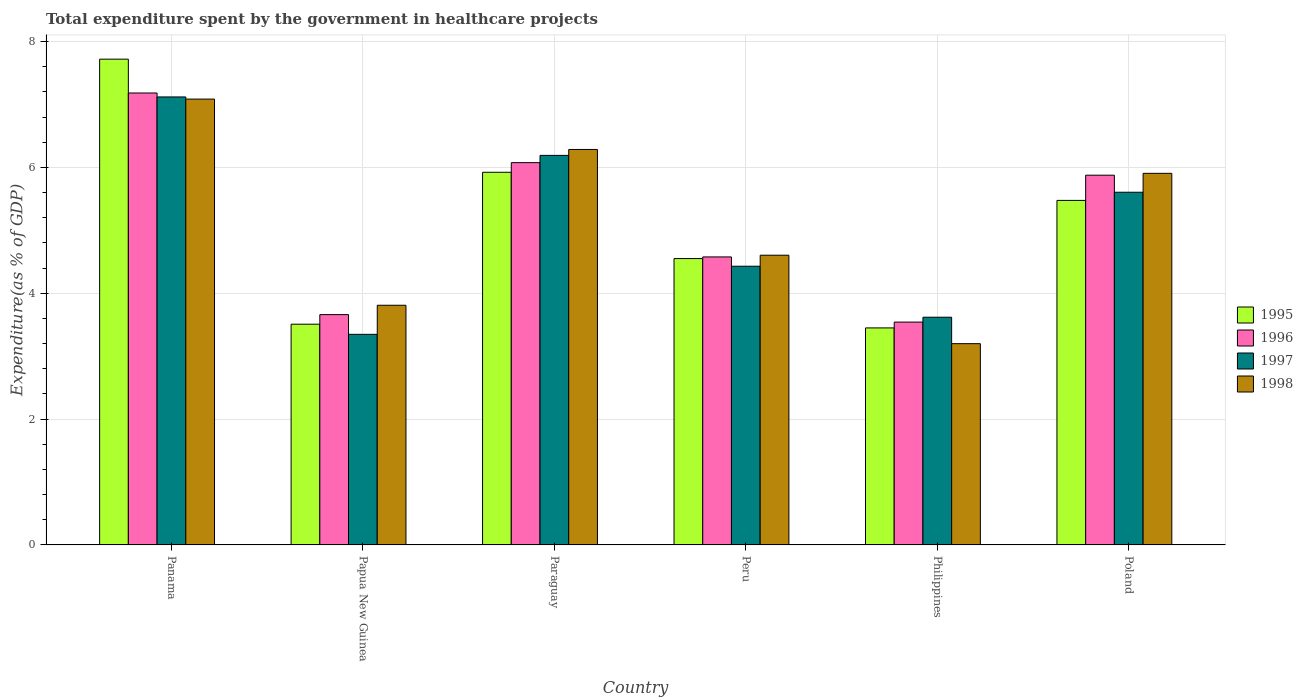How many different coloured bars are there?
Your answer should be compact. 4. Are the number of bars per tick equal to the number of legend labels?
Provide a succinct answer. Yes. What is the total expenditure spent by the government in healthcare projects in 1998 in Poland?
Give a very brief answer. 5.91. Across all countries, what is the maximum total expenditure spent by the government in healthcare projects in 1996?
Make the answer very short. 7.18. Across all countries, what is the minimum total expenditure spent by the government in healthcare projects in 1998?
Make the answer very short. 3.2. In which country was the total expenditure spent by the government in healthcare projects in 1995 maximum?
Offer a very short reply. Panama. In which country was the total expenditure spent by the government in healthcare projects in 1996 minimum?
Provide a short and direct response. Philippines. What is the total total expenditure spent by the government in healthcare projects in 1996 in the graph?
Give a very brief answer. 30.91. What is the difference between the total expenditure spent by the government in healthcare projects in 1995 in Papua New Guinea and that in Paraguay?
Make the answer very short. -2.41. What is the difference between the total expenditure spent by the government in healthcare projects in 1997 in Philippines and the total expenditure spent by the government in healthcare projects in 1996 in Peru?
Give a very brief answer. -0.96. What is the average total expenditure spent by the government in healthcare projects in 1996 per country?
Your answer should be compact. 5.15. What is the difference between the total expenditure spent by the government in healthcare projects of/in 1998 and total expenditure spent by the government in healthcare projects of/in 1996 in Peru?
Your answer should be compact. 0.03. What is the ratio of the total expenditure spent by the government in healthcare projects in 1995 in Philippines to that in Poland?
Provide a succinct answer. 0.63. What is the difference between the highest and the second highest total expenditure spent by the government in healthcare projects in 1998?
Your answer should be compact. -0.38. What is the difference between the highest and the lowest total expenditure spent by the government in healthcare projects in 1995?
Your response must be concise. 4.27. In how many countries, is the total expenditure spent by the government in healthcare projects in 1995 greater than the average total expenditure spent by the government in healthcare projects in 1995 taken over all countries?
Offer a terse response. 3. Is it the case that in every country, the sum of the total expenditure spent by the government in healthcare projects in 1997 and total expenditure spent by the government in healthcare projects in 1995 is greater than the sum of total expenditure spent by the government in healthcare projects in 1996 and total expenditure spent by the government in healthcare projects in 1998?
Ensure brevity in your answer.  No. Is it the case that in every country, the sum of the total expenditure spent by the government in healthcare projects in 1995 and total expenditure spent by the government in healthcare projects in 1996 is greater than the total expenditure spent by the government in healthcare projects in 1998?
Offer a terse response. Yes. Are all the bars in the graph horizontal?
Offer a very short reply. No. What is the difference between two consecutive major ticks on the Y-axis?
Keep it short and to the point. 2. How many legend labels are there?
Your answer should be compact. 4. How are the legend labels stacked?
Ensure brevity in your answer.  Vertical. What is the title of the graph?
Your response must be concise. Total expenditure spent by the government in healthcare projects. What is the label or title of the Y-axis?
Give a very brief answer. Expenditure(as % of GDP). What is the Expenditure(as % of GDP) in 1995 in Panama?
Your answer should be very brief. 7.72. What is the Expenditure(as % of GDP) in 1996 in Panama?
Give a very brief answer. 7.18. What is the Expenditure(as % of GDP) of 1997 in Panama?
Make the answer very short. 7.12. What is the Expenditure(as % of GDP) in 1998 in Panama?
Offer a very short reply. 7.09. What is the Expenditure(as % of GDP) in 1995 in Papua New Guinea?
Offer a very short reply. 3.51. What is the Expenditure(as % of GDP) in 1996 in Papua New Guinea?
Your answer should be compact. 3.66. What is the Expenditure(as % of GDP) in 1997 in Papua New Guinea?
Your answer should be compact. 3.35. What is the Expenditure(as % of GDP) in 1998 in Papua New Guinea?
Provide a short and direct response. 3.81. What is the Expenditure(as % of GDP) of 1995 in Paraguay?
Give a very brief answer. 5.92. What is the Expenditure(as % of GDP) in 1996 in Paraguay?
Your answer should be very brief. 6.08. What is the Expenditure(as % of GDP) of 1997 in Paraguay?
Keep it short and to the point. 6.19. What is the Expenditure(as % of GDP) in 1998 in Paraguay?
Provide a succinct answer. 6.29. What is the Expenditure(as % of GDP) of 1995 in Peru?
Offer a very short reply. 4.55. What is the Expenditure(as % of GDP) of 1996 in Peru?
Give a very brief answer. 4.58. What is the Expenditure(as % of GDP) in 1997 in Peru?
Your answer should be compact. 4.43. What is the Expenditure(as % of GDP) in 1998 in Peru?
Offer a terse response. 4.6. What is the Expenditure(as % of GDP) of 1995 in Philippines?
Your response must be concise. 3.45. What is the Expenditure(as % of GDP) of 1996 in Philippines?
Your answer should be compact. 3.54. What is the Expenditure(as % of GDP) in 1997 in Philippines?
Your response must be concise. 3.62. What is the Expenditure(as % of GDP) of 1998 in Philippines?
Give a very brief answer. 3.2. What is the Expenditure(as % of GDP) of 1995 in Poland?
Provide a succinct answer. 5.48. What is the Expenditure(as % of GDP) in 1996 in Poland?
Ensure brevity in your answer.  5.88. What is the Expenditure(as % of GDP) of 1997 in Poland?
Your answer should be very brief. 5.61. What is the Expenditure(as % of GDP) in 1998 in Poland?
Your answer should be compact. 5.91. Across all countries, what is the maximum Expenditure(as % of GDP) in 1995?
Offer a very short reply. 7.72. Across all countries, what is the maximum Expenditure(as % of GDP) in 1996?
Keep it short and to the point. 7.18. Across all countries, what is the maximum Expenditure(as % of GDP) of 1997?
Offer a terse response. 7.12. Across all countries, what is the maximum Expenditure(as % of GDP) in 1998?
Make the answer very short. 7.09. Across all countries, what is the minimum Expenditure(as % of GDP) of 1995?
Your answer should be very brief. 3.45. Across all countries, what is the minimum Expenditure(as % of GDP) of 1996?
Offer a terse response. 3.54. Across all countries, what is the minimum Expenditure(as % of GDP) of 1997?
Offer a terse response. 3.35. Across all countries, what is the minimum Expenditure(as % of GDP) of 1998?
Provide a short and direct response. 3.2. What is the total Expenditure(as % of GDP) in 1995 in the graph?
Your answer should be very brief. 30.63. What is the total Expenditure(as % of GDP) in 1996 in the graph?
Offer a very short reply. 30.91. What is the total Expenditure(as % of GDP) of 1997 in the graph?
Your answer should be compact. 30.31. What is the total Expenditure(as % of GDP) of 1998 in the graph?
Provide a succinct answer. 30.89. What is the difference between the Expenditure(as % of GDP) in 1995 in Panama and that in Papua New Guinea?
Your answer should be very brief. 4.21. What is the difference between the Expenditure(as % of GDP) of 1996 in Panama and that in Papua New Guinea?
Provide a short and direct response. 3.52. What is the difference between the Expenditure(as % of GDP) in 1997 in Panama and that in Papua New Guinea?
Ensure brevity in your answer.  3.77. What is the difference between the Expenditure(as % of GDP) of 1998 in Panama and that in Papua New Guinea?
Make the answer very short. 3.28. What is the difference between the Expenditure(as % of GDP) in 1995 in Panama and that in Paraguay?
Provide a short and direct response. 1.8. What is the difference between the Expenditure(as % of GDP) in 1996 in Panama and that in Paraguay?
Your answer should be compact. 1.11. What is the difference between the Expenditure(as % of GDP) of 1997 in Panama and that in Paraguay?
Provide a short and direct response. 0.93. What is the difference between the Expenditure(as % of GDP) of 1998 in Panama and that in Paraguay?
Make the answer very short. 0.8. What is the difference between the Expenditure(as % of GDP) of 1995 in Panama and that in Peru?
Provide a short and direct response. 3.17. What is the difference between the Expenditure(as % of GDP) of 1996 in Panama and that in Peru?
Offer a terse response. 2.61. What is the difference between the Expenditure(as % of GDP) of 1997 in Panama and that in Peru?
Make the answer very short. 2.69. What is the difference between the Expenditure(as % of GDP) in 1998 in Panama and that in Peru?
Offer a very short reply. 2.48. What is the difference between the Expenditure(as % of GDP) of 1995 in Panama and that in Philippines?
Make the answer very short. 4.27. What is the difference between the Expenditure(as % of GDP) of 1996 in Panama and that in Philippines?
Your response must be concise. 3.64. What is the difference between the Expenditure(as % of GDP) of 1997 in Panama and that in Philippines?
Ensure brevity in your answer.  3.5. What is the difference between the Expenditure(as % of GDP) of 1998 in Panama and that in Philippines?
Your answer should be very brief. 3.89. What is the difference between the Expenditure(as % of GDP) in 1995 in Panama and that in Poland?
Offer a very short reply. 2.24. What is the difference between the Expenditure(as % of GDP) in 1996 in Panama and that in Poland?
Keep it short and to the point. 1.31. What is the difference between the Expenditure(as % of GDP) of 1997 in Panama and that in Poland?
Offer a very short reply. 1.51. What is the difference between the Expenditure(as % of GDP) of 1998 in Panama and that in Poland?
Provide a short and direct response. 1.18. What is the difference between the Expenditure(as % of GDP) in 1995 in Papua New Guinea and that in Paraguay?
Provide a short and direct response. -2.41. What is the difference between the Expenditure(as % of GDP) in 1996 in Papua New Guinea and that in Paraguay?
Your answer should be compact. -2.42. What is the difference between the Expenditure(as % of GDP) of 1997 in Papua New Guinea and that in Paraguay?
Offer a terse response. -2.84. What is the difference between the Expenditure(as % of GDP) of 1998 in Papua New Guinea and that in Paraguay?
Give a very brief answer. -2.48. What is the difference between the Expenditure(as % of GDP) of 1995 in Papua New Guinea and that in Peru?
Your response must be concise. -1.04. What is the difference between the Expenditure(as % of GDP) of 1996 in Papua New Guinea and that in Peru?
Give a very brief answer. -0.92. What is the difference between the Expenditure(as % of GDP) in 1997 in Papua New Guinea and that in Peru?
Provide a short and direct response. -1.08. What is the difference between the Expenditure(as % of GDP) in 1998 in Papua New Guinea and that in Peru?
Make the answer very short. -0.8. What is the difference between the Expenditure(as % of GDP) in 1995 in Papua New Guinea and that in Philippines?
Provide a short and direct response. 0.06. What is the difference between the Expenditure(as % of GDP) of 1996 in Papua New Guinea and that in Philippines?
Offer a very short reply. 0.12. What is the difference between the Expenditure(as % of GDP) in 1997 in Papua New Guinea and that in Philippines?
Your response must be concise. -0.27. What is the difference between the Expenditure(as % of GDP) in 1998 in Papua New Guinea and that in Philippines?
Offer a very short reply. 0.61. What is the difference between the Expenditure(as % of GDP) in 1995 in Papua New Guinea and that in Poland?
Give a very brief answer. -1.97. What is the difference between the Expenditure(as % of GDP) in 1996 in Papua New Guinea and that in Poland?
Give a very brief answer. -2.22. What is the difference between the Expenditure(as % of GDP) in 1997 in Papua New Guinea and that in Poland?
Keep it short and to the point. -2.26. What is the difference between the Expenditure(as % of GDP) in 1998 in Papua New Guinea and that in Poland?
Your response must be concise. -2.1. What is the difference between the Expenditure(as % of GDP) of 1995 in Paraguay and that in Peru?
Ensure brevity in your answer.  1.37. What is the difference between the Expenditure(as % of GDP) of 1996 in Paraguay and that in Peru?
Your response must be concise. 1.5. What is the difference between the Expenditure(as % of GDP) of 1997 in Paraguay and that in Peru?
Offer a very short reply. 1.76. What is the difference between the Expenditure(as % of GDP) of 1998 in Paraguay and that in Peru?
Give a very brief answer. 1.68. What is the difference between the Expenditure(as % of GDP) of 1995 in Paraguay and that in Philippines?
Provide a short and direct response. 2.47. What is the difference between the Expenditure(as % of GDP) of 1996 in Paraguay and that in Philippines?
Provide a succinct answer. 2.53. What is the difference between the Expenditure(as % of GDP) of 1997 in Paraguay and that in Philippines?
Provide a short and direct response. 2.57. What is the difference between the Expenditure(as % of GDP) of 1998 in Paraguay and that in Philippines?
Offer a terse response. 3.09. What is the difference between the Expenditure(as % of GDP) of 1995 in Paraguay and that in Poland?
Your answer should be very brief. 0.45. What is the difference between the Expenditure(as % of GDP) of 1996 in Paraguay and that in Poland?
Give a very brief answer. 0.2. What is the difference between the Expenditure(as % of GDP) of 1997 in Paraguay and that in Poland?
Provide a short and direct response. 0.59. What is the difference between the Expenditure(as % of GDP) in 1998 in Paraguay and that in Poland?
Provide a succinct answer. 0.38. What is the difference between the Expenditure(as % of GDP) of 1995 in Peru and that in Philippines?
Your answer should be very brief. 1.1. What is the difference between the Expenditure(as % of GDP) of 1996 in Peru and that in Philippines?
Provide a short and direct response. 1.04. What is the difference between the Expenditure(as % of GDP) of 1997 in Peru and that in Philippines?
Your answer should be compact. 0.81. What is the difference between the Expenditure(as % of GDP) of 1998 in Peru and that in Philippines?
Provide a succinct answer. 1.41. What is the difference between the Expenditure(as % of GDP) of 1995 in Peru and that in Poland?
Your answer should be compact. -0.92. What is the difference between the Expenditure(as % of GDP) in 1996 in Peru and that in Poland?
Your response must be concise. -1.3. What is the difference between the Expenditure(as % of GDP) in 1997 in Peru and that in Poland?
Offer a very short reply. -1.18. What is the difference between the Expenditure(as % of GDP) in 1998 in Peru and that in Poland?
Give a very brief answer. -1.3. What is the difference between the Expenditure(as % of GDP) in 1995 in Philippines and that in Poland?
Offer a very short reply. -2.03. What is the difference between the Expenditure(as % of GDP) in 1996 in Philippines and that in Poland?
Offer a terse response. -2.33. What is the difference between the Expenditure(as % of GDP) of 1997 in Philippines and that in Poland?
Provide a succinct answer. -1.99. What is the difference between the Expenditure(as % of GDP) of 1998 in Philippines and that in Poland?
Keep it short and to the point. -2.71. What is the difference between the Expenditure(as % of GDP) in 1995 in Panama and the Expenditure(as % of GDP) in 1996 in Papua New Guinea?
Your response must be concise. 4.06. What is the difference between the Expenditure(as % of GDP) of 1995 in Panama and the Expenditure(as % of GDP) of 1997 in Papua New Guinea?
Keep it short and to the point. 4.37. What is the difference between the Expenditure(as % of GDP) of 1995 in Panama and the Expenditure(as % of GDP) of 1998 in Papua New Guinea?
Your answer should be compact. 3.91. What is the difference between the Expenditure(as % of GDP) in 1996 in Panama and the Expenditure(as % of GDP) in 1997 in Papua New Guinea?
Make the answer very short. 3.84. What is the difference between the Expenditure(as % of GDP) in 1996 in Panama and the Expenditure(as % of GDP) in 1998 in Papua New Guinea?
Make the answer very short. 3.37. What is the difference between the Expenditure(as % of GDP) in 1997 in Panama and the Expenditure(as % of GDP) in 1998 in Papua New Guinea?
Your answer should be very brief. 3.31. What is the difference between the Expenditure(as % of GDP) of 1995 in Panama and the Expenditure(as % of GDP) of 1996 in Paraguay?
Make the answer very short. 1.64. What is the difference between the Expenditure(as % of GDP) in 1995 in Panama and the Expenditure(as % of GDP) in 1997 in Paraguay?
Provide a short and direct response. 1.53. What is the difference between the Expenditure(as % of GDP) in 1995 in Panama and the Expenditure(as % of GDP) in 1998 in Paraguay?
Give a very brief answer. 1.44. What is the difference between the Expenditure(as % of GDP) of 1996 in Panama and the Expenditure(as % of GDP) of 1997 in Paraguay?
Offer a very short reply. 0.99. What is the difference between the Expenditure(as % of GDP) in 1996 in Panama and the Expenditure(as % of GDP) in 1998 in Paraguay?
Give a very brief answer. 0.9. What is the difference between the Expenditure(as % of GDP) in 1997 in Panama and the Expenditure(as % of GDP) in 1998 in Paraguay?
Offer a terse response. 0.83. What is the difference between the Expenditure(as % of GDP) in 1995 in Panama and the Expenditure(as % of GDP) in 1996 in Peru?
Your answer should be compact. 3.14. What is the difference between the Expenditure(as % of GDP) of 1995 in Panama and the Expenditure(as % of GDP) of 1997 in Peru?
Keep it short and to the point. 3.29. What is the difference between the Expenditure(as % of GDP) in 1995 in Panama and the Expenditure(as % of GDP) in 1998 in Peru?
Your answer should be compact. 3.12. What is the difference between the Expenditure(as % of GDP) in 1996 in Panama and the Expenditure(as % of GDP) in 1997 in Peru?
Provide a short and direct response. 2.75. What is the difference between the Expenditure(as % of GDP) in 1996 in Panama and the Expenditure(as % of GDP) in 1998 in Peru?
Keep it short and to the point. 2.58. What is the difference between the Expenditure(as % of GDP) in 1997 in Panama and the Expenditure(as % of GDP) in 1998 in Peru?
Provide a short and direct response. 2.52. What is the difference between the Expenditure(as % of GDP) of 1995 in Panama and the Expenditure(as % of GDP) of 1996 in Philippines?
Make the answer very short. 4.18. What is the difference between the Expenditure(as % of GDP) of 1995 in Panama and the Expenditure(as % of GDP) of 1997 in Philippines?
Your answer should be very brief. 4.1. What is the difference between the Expenditure(as % of GDP) of 1995 in Panama and the Expenditure(as % of GDP) of 1998 in Philippines?
Keep it short and to the point. 4.52. What is the difference between the Expenditure(as % of GDP) of 1996 in Panama and the Expenditure(as % of GDP) of 1997 in Philippines?
Your answer should be compact. 3.56. What is the difference between the Expenditure(as % of GDP) in 1996 in Panama and the Expenditure(as % of GDP) in 1998 in Philippines?
Make the answer very short. 3.98. What is the difference between the Expenditure(as % of GDP) of 1997 in Panama and the Expenditure(as % of GDP) of 1998 in Philippines?
Give a very brief answer. 3.92. What is the difference between the Expenditure(as % of GDP) in 1995 in Panama and the Expenditure(as % of GDP) in 1996 in Poland?
Your answer should be very brief. 1.84. What is the difference between the Expenditure(as % of GDP) in 1995 in Panama and the Expenditure(as % of GDP) in 1997 in Poland?
Provide a succinct answer. 2.12. What is the difference between the Expenditure(as % of GDP) of 1995 in Panama and the Expenditure(as % of GDP) of 1998 in Poland?
Give a very brief answer. 1.81. What is the difference between the Expenditure(as % of GDP) in 1996 in Panama and the Expenditure(as % of GDP) in 1997 in Poland?
Keep it short and to the point. 1.58. What is the difference between the Expenditure(as % of GDP) in 1996 in Panama and the Expenditure(as % of GDP) in 1998 in Poland?
Provide a short and direct response. 1.28. What is the difference between the Expenditure(as % of GDP) of 1997 in Panama and the Expenditure(as % of GDP) of 1998 in Poland?
Offer a very short reply. 1.21. What is the difference between the Expenditure(as % of GDP) of 1995 in Papua New Guinea and the Expenditure(as % of GDP) of 1996 in Paraguay?
Keep it short and to the point. -2.57. What is the difference between the Expenditure(as % of GDP) of 1995 in Papua New Guinea and the Expenditure(as % of GDP) of 1997 in Paraguay?
Your answer should be very brief. -2.68. What is the difference between the Expenditure(as % of GDP) of 1995 in Papua New Guinea and the Expenditure(as % of GDP) of 1998 in Paraguay?
Ensure brevity in your answer.  -2.78. What is the difference between the Expenditure(as % of GDP) in 1996 in Papua New Guinea and the Expenditure(as % of GDP) in 1997 in Paraguay?
Offer a terse response. -2.53. What is the difference between the Expenditure(as % of GDP) in 1996 in Papua New Guinea and the Expenditure(as % of GDP) in 1998 in Paraguay?
Make the answer very short. -2.62. What is the difference between the Expenditure(as % of GDP) of 1997 in Papua New Guinea and the Expenditure(as % of GDP) of 1998 in Paraguay?
Provide a succinct answer. -2.94. What is the difference between the Expenditure(as % of GDP) in 1995 in Papua New Guinea and the Expenditure(as % of GDP) in 1996 in Peru?
Your answer should be compact. -1.07. What is the difference between the Expenditure(as % of GDP) in 1995 in Papua New Guinea and the Expenditure(as % of GDP) in 1997 in Peru?
Your response must be concise. -0.92. What is the difference between the Expenditure(as % of GDP) in 1995 in Papua New Guinea and the Expenditure(as % of GDP) in 1998 in Peru?
Your answer should be compact. -1.1. What is the difference between the Expenditure(as % of GDP) of 1996 in Papua New Guinea and the Expenditure(as % of GDP) of 1997 in Peru?
Your answer should be very brief. -0.77. What is the difference between the Expenditure(as % of GDP) of 1996 in Papua New Guinea and the Expenditure(as % of GDP) of 1998 in Peru?
Your answer should be compact. -0.94. What is the difference between the Expenditure(as % of GDP) in 1997 in Papua New Guinea and the Expenditure(as % of GDP) in 1998 in Peru?
Your answer should be compact. -1.26. What is the difference between the Expenditure(as % of GDP) of 1995 in Papua New Guinea and the Expenditure(as % of GDP) of 1996 in Philippines?
Provide a succinct answer. -0.03. What is the difference between the Expenditure(as % of GDP) of 1995 in Papua New Guinea and the Expenditure(as % of GDP) of 1997 in Philippines?
Keep it short and to the point. -0.11. What is the difference between the Expenditure(as % of GDP) of 1995 in Papua New Guinea and the Expenditure(as % of GDP) of 1998 in Philippines?
Offer a very short reply. 0.31. What is the difference between the Expenditure(as % of GDP) of 1996 in Papua New Guinea and the Expenditure(as % of GDP) of 1997 in Philippines?
Your answer should be very brief. 0.04. What is the difference between the Expenditure(as % of GDP) of 1996 in Papua New Guinea and the Expenditure(as % of GDP) of 1998 in Philippines?
Give a very brief answer. 0.46. What is the difference between the Expenditure(as % of GDP) in 1997 in Papua New Guinea and the Expenditure(as % of GDP) in 1998 in Philippines?
Offer a very short reply. 0.15. What is the difference between the Expenditure(as % of GDP) in 1995 in Papua New Guinea and the Expenditure(as % of GDP) in 1996 in Poland?
Keep it short and to the point. -2.37. What is the difference between the Expenditure(as % of GDP) in 1995 in Papua New Guinea and the Expenditure(as % of GDP) in 1997 in Poland?
Provide a succinct answer. -2.1. What is the difference between the Expenditure(as % of GDP) of 1995 in Papua New Guinea and the Expenditure(as % of GDP) of 1998 in Poland?
Keep it short and to the point. -2.4. What is the difference between the Expenditure(as % of GDP) in 1996 in Papua New Guinea and the Expenditure(as % of GDP) in 1997 in Poland?
Make the answer very short. -1.95. What is the difference between the Expenditure(as % of GDP) in 1996 in Papua New Guinea and the Expenditure(as % of GDP) in 1998 in Poland?
Your response must be concise. -2.25. What is the difference between the Expenditure(as % of GDP) in 1997 in Papua New Guinea and the Expenditure(as % of GDP) in 1998 in Poland?
Your answer should be compact. -2.56. What is the difference between the Expenditure(as % of GDP) of 1995 in Paraguay and the Expenditure(as % of GDP) of 1996 in Peru?
Ensure brevity in your answer.  1.35. What is the difference between the Expenditure(as % of GDP) in 1995 in Paraguay and the Expenditure(as % of GDP) in 1997 in Peru?
Ensure brevity in your answer.  1.49. What is the difference between the Expenditure(as % of GDP) in 1995 in Paraguay and the Expenditure(as % of GDP) in 1998 in Peru?
Provide a short and direct response. 1.32. What is the difference between the Expenditure(as % of GDP) of 1996 in Paraguay and the Expenditure(as % of GDP) of 1997 in Peru?
Provide a succinct answer. 1.65. What is the difference between the Expenditure(as % of GDP) in 1996 in Paraguay and the Expenditure(as % of GDP) in 1998 in Peru?
Provide a short and direct response. 1.47. What is the difference between the Expenditure(as % of GDP) of 1997 in Paraguay and the Expenditure(as % of GDP) of 1998 in Peru?
Offer a terse response. 1.59. What is the difference between the Expenditure(as % of GDP) of 1995 in Paraguay and the Expenditure(as % of GDP) of 1996 in Philippines?
Offer a very short reply. 2.38. What is the difference between the Expenditure(as % of GDP) in 1995 in Paraguay and the Expenditure(as % of GDP) in 1997 in Philippines?
Your response must be concise. 2.3. What is the difference between the Expenditure(as % of GDP) in 1995 in Paraguay and the Expenditure(as % of GDP) in 1998 in Philippines?
Offer a terse response. 2.72. What is the difference between the Expenditure(as % of GDP) of 1996 in Paraguay and the Expenditure(as % of GDP) of 1997 in Philippines?
Keep it short and to the point. 2.46. What is the difference between the Expenditure(as % of GDP) of 1996 in Paraguay and the Expenditure(as % of GDP) of 1998 in Philippines?
Offer a terse response. 2.88. What is the difference between the Expenditure(as % of GDP) of 1997 in Paraguay and the Expenditure(as % of GDP) of 1998 in Philippines?
Your answer should be compact. 2.99. What is the difference between the Expenditure(as % of GDP) of 1995 in Paraguay and the Expenditure(as % of GDP) of 1996 in Poland?
Provide a short and direct response. 0.05. What is the difference between the Expenditure(as % of GDP) in 1995 in Paraguay and the Expenditure(as % of GDP) in 1997 in Poland?
Your response must be concise. 0.32. What is the difference between the Expenditure(as % of GDP) of 1995 in Paraguay and the Expenditure(as % of GDP) of 1998 in Poland?
Ensure brevity in your answer.  0.02. What is the difference between the Expenditure(as % of GDP) in 1996 in Paraguay and the Expenditure(as % of GDP) in 1997 in Poland?
Give a very brief answer. 0.47. What is the difference between the Expenditure(as % of GDP) of 1996 in Paraguay and the Expenditure(as % of GDP) of 1998 in Poland?
Give a very brief answer. 0.17. What is the difference between the Expenditure(as % of GDP) in 1997 in Paraguay and the Expenditure(as % of GDP) in 1998 in Poland?
Your answer should be very brief. 0.29. What is the difference between the Expenditure(as % of GDP) in 1995 in Peru and the Expenditure(as % of GDP) in 1996 in Philippines?
Provide a short and direct response. 1.01. What is the difference between the Expenditure(as % of GDP) in 1995 in Peru and the Expenditure(as % of GDP) in 1997 in Philippines?
Your answer should be compact. 0.93. What is the difference between the Expenditure(as % of GDP) in 1995 in Peru and the Expenditure(as % of GDP) in 1998 in Philippines?
Your answer should be compact. 1.35. What is the difference between the Expenditure(as % of GDP) of 1996 in Peru and the Expenditure(as % of GDP) of 1997 in Philippines?
Provide a succinct answer. 0.96. What is the difference between the Expenditure(as % of GDP) in 1996 in Peru and the Expenditure(as % of GDP) in 1998 in Philippines?
Offer a very short reply. 1.38. What is the difference between the Expenditure(as % of GDP) of 1997 in Peru and the Expenditure(as % of GDP) of 1998 in Philippines?
Your response must be concise. 1.23. What is the difference between the Expenditure(as % of GDP) of 1995 in Peru and the Expenditure(as % of GDP) of 1996 in Poland?
Provide a succinct answer. -1.32. What is the difference between the Expenditure(as % of GDP) in 1995 in Peru and the Expenditure(as % of GDP) in 1997 in Poland?
Keep it short and to the point. -1.05. What is the difference between the Expenditure(as % of GDP) in 1995 in Peru and the Expenditure(as % of GDP) in 1998 in Poland?
Provide a succinct answer. -1.35. What is the difference between the Expenditure(as % of GDP) of 1996 in Peru and the Expenditure(as % of GDP) of 1997 in Poland?
Your response must be concise. -1.03. What is the difference between the Expenditure(as % of GDP) in 1996 in Peru and the Expenditure(as % of GDP) in 1998 in Poland?
Provide a short and direct response. -1.33. What is the difference between the Expenditure(as % of GDP) of 1997 in Peru and the Expenditure(as % of GDP) of 1998 in Poland?
Give a very brief answer. -1.48. What is the difference between the Expenditure(as % of GDP) of 1995 in Philippines and the Expenditure(as % of GDP) of 1996 in Poland?
Ensure brevity in your answer.  -2.43. What is the difference between the Expenditure(as % of GDP) of 1995 in Philippines and the Expenditure(as % of GDP) of 1997 in Poland?
Your response must be concise. -2.16. What is the difference between the Expenditure(as % of GDP) in 1995 in Philippines and the Expenditure(as % of GDP) in 1998 in Poland?
Ensure brevity in your answer.  -2.46. What is the difference between the Expenditure(as % of GDP) in 1996 in Philippines and the Expenditure(as % of GDP) in 1997 in Poland?
Offer a terse response. -2.06. What is the difference between the Expenditure(as % of GDP) in 1996 in Philippines and the Expenditure(as % of GDP) in 1998 in Poland?
Offer a terse response. -2.36. What is the difference between the Expenditure(as % of GDP) of 1997 in Philippines and the Expenditure(as % of GDP) of 1998 in Poland?
Provide a succinct answer. -2.29. What is the average Expenditure(as % of GDP) in 1995 per country?
Make the answer very short. 5.1. What is the average Expenditure(as % of GDP) of 1996 per country?
Your response must be concise. 5.15. What is the average Expenditure(as % of GDP) of 1997 per country?
Make the answer very short. 5.05. What is the average Expenditure(as % of GDP) in 1998 per country?
Provide a succinct answer. 5.15. What is the difference between the Expenditure(as % of GDP) in 1995 and Expenditure(as % of GDP) in 1996 in Panama?
Your answer should be compact. 0.54. What is the difference between the Expenditure(as % of GDP) in 1995 and Expenditure(as % of GDP) in 1997 in Panama?
Ensure brevity in your answer.  0.6. What is the difference between the Expenditure(as % of GDP) in 1995 and Expenditure(as % of GDP) in 1998 in Panama?
Your response must be concise. 0.63. What is the difference between the Expenditure(as % of GDP) of 1996 and Expenditure(as % of GDP) of 1997 in Panama?
Offer a very short reply. 0.06. What is the difference between the Expenditure(as % of GDP) of 1996 and Expenditure(as % of GDP) of 1998 in Panama?
Your response must be concise. 0.1. What is the difference between the Expenditure(as % of GDP) of 1997 and Expenditure(as % of GDP) of 1998 in Panama?
Your answer should be compact. 0.03. What is the difference between the Expenditure(as % of GDP) in 1995 and Expenditure(as % of GDP) in 1996 in Papua New Guinea?
Offer a terse response. -0.15. What is the difference between the Expenditure(as % of GDP) of 1995 and Expenditure(as % of GDP) of 1997 in Papua New Guinea?
Offer a terse response. 0.16. What is the difference between the Expenditure(as % of GDP) in 1995 and Expenditure(as % of GDP) in 1998 in Papua New Guinea?
Make the answer very short. -0.3. What is the difference between the Expenditure(as % of GDP) of 1996 and Expenditure(as % of GDP) of 1997 in Papua New Guinea?
Provide a succinct answer. 0.31. What is the difference between the Expenditure(as % of GDP) in 1996 and Expenditure(as % of GDP) in 1998 in Papua New Guinea?
Your answer should be compact. -0.15. What is the difference between the Expenditure(as % of GDP) in 1997 and Expenditure(as % of GDP) in 1998 in Papua New Guinea?
Provide a short and direct response. -0.46. What is the difference between the Expenditure(as % of GDP) in 1995 and Expenditure(as % of GDP) in 1996 in Paraguay?
Make the answer very short. -0.15. What is the difference between the Expenditure(as % of GDP) in 1995 and Expenditure(as % of GDP) in 1997 in Paraguay?
Your answer should be compact. -0.27. What is the difference between the Expenditure(as % of GDP) in 1995 and Expenditure(as % of GDP) in 1998 in Paraguay?
Provide a short and direct response. -0.36. What is the difference between the Expenditure(as % of GDP) of 1996 and Expenditure(as % of GDP) of 1997 in Paraguay?
Offer a very short reply. -0.12. What is the difference between the Expenditure(as % of GDP) in 1996 and Expenditure(as % of GDP) in 1998 in Paraguay?
Your answer should be compact. -0.21. What is the difference between the Expenditure(as % of GDP) of 1997 and Expenditure(as % of GDP) of 1998 in Paraguay?
Provide a short and direct response. -0.09. What is the difference between the Expenditure(as % of GDP) of 1995 and Expenditure(as % of GDP) of 1996 in Peru?
Provide a succinct answer. -0.03. What is the difference between the Expenditure(as % of GDP) in 1995 and Expenditure(as % of GDP) in 1997 in Peru?
Ensure brevity in your answer.  0.12. What is the difference between the Expenditure(as % of GDP) of 1995 and Expenditure(as % of GDP) of 1998 in Peru?
Your response must be concise. -0.05. What is the difference between the Expenditure(as % of GDP) of 1996 and Expenditure(as % of GDP) of 1997 in Peru?
Your answer should be very brief. 0.15. What is the difference between the Expenditure(as % of GDP) in 1996 and Expenditure(as % of GDP) in 1998 in Peru?
Keep it short and to the point. -0.03. What is the difference between the Expenditure(as % of GDP) in 1997 and Expenditure(as % of GDP) in 1998 in Peru?
Your answer should be compact. -0.17. What is the difference between the Expenditure(as % of GDP) in 1995 and Expenditure(as % of GDP) in 1996 in Philippines?
Offer a very short reply. -0.09. What is the difference between the Expenditure(as % of GDP) in 1995 and Expenditure(as % of GDP) in 1997 in Philippines?
Ensure brevity in your answer.  -0.17. What is the difference between the Expenditure(as % of GDP) in 1995 and Expenditure(as % of GDP) in 1998 in Philippines?
Provide a succinct answer. 0.25. What is the difference between the Expenditure(as % of GDP) of 1996 and Expenditure(as % of GDP) of 1997 in Philippines?
Ensure brevity in your answer.  -0.08. What is the difference between the Expenditure(as % of GDP) of 1996 and Expenditure(as % of GDP) of 1998 in Philippines?
Make the answer very short. 0.34. What is the difference between the Expenditure(as % of GDP) in 1997 and Expenditure(as % of GDP) in 1998 in Philippines?
Your response must be concise. 0.42. What is the difference between the Expenditure(as % of GDP) in 1995 and Expenditure(as % of GDP) in 1996 in Poland?
Your answer should be very brief. -0.4. What is the difference between the Expenditure(as % of GDP) in 1995 and Expenditure(as % of GDP) in 1997 in Poland?
Provide a succinct answer. -0.13. What is the difference between the Expenditure(as % of GDP) in 1995 and Expenditure(as % of GDP) in 1998 in Poland?
Provide a short and direct response. -0.43. What is the difference between the Expenditure(as % of GDP) of 1996 and Expenditure(as % of GDP) of 1997 in Poland?
Provide a short and direct response. 0.27. What is the difference between the Expenditure(as % of GDP) of 1996 and Expenditure(as % of GDP) of 1998 in Poland?
Give a very brief answer. -0.03. What is the difference between the Expenditure(as % of GDP) of 1997 and Expenditure(as % of GDP) of 1998 in Poland?
Your answer should be compact. -0.3. What is the ratio of the Expenditure(as % of GDP) in 1995 in Panama to that in Papua New Guinea?
Ensure brevity in your answer.  2.2. What is the ratio of the Expenditure(as % of GDP) in 1996 in Panama to that in Papua New Guinea?
Offer a terse response. 1.96. What is the ratio of the Expenditure(as % of GDP) of 1997 in Panama to that in Papua New Guinea?
Make the answer very short. 2.13. What is the ratio of the Expenditure(as % of GDP) of 1998 in Panama to that in Papua New Guinea?
Offer a very short reply. 1.86. What is the ratio of the Expenditure(as % of GDP) in 1995 in Panama to that in Paraguay?
Provide a short and direct response. 1.3. What is the ratio of the Expenditure(as % of GDP) of 1996 in Panama to that in Paraguay?
Make the answer very short. 1.18. What is the ratio of the Expenditure(as % of GDP) of 1997 in Panama to that in Paraguay?
Your response must be concise. 1.15. What is the ratio of the Expenditure(as % of GDP) of 1998 in Panama to that in Paraguay?
Offer a very short reply. 1.13. What is the ratio of the Expenditure(as % of GDP) of 1995 in Panama to that in Peru?
Provide a short and direct response. 1.7. What is the ratio of the Expenditure(as % of GDP) in 1996 in Panama to that in Peru?
Your response must be concise. 1.57. What is the ratio of the Expenditure(as % of GDP) in 1997 in Panama to that in Peru?
Give a very brief answer. 1.61. What is the ratio of the Expenditure(as % of GDP) in 1998 in Panama to that in Peru?
Your response must be concise. 1.54. What is the ratio of the Expenditure(as % of GDP) of 1995 in Panama to that in Philippines?
Keep it short and to the point. 2.24. What is the ratio of the Expenditure(as % of GDP) in 1996 in Panama to that in Philippines?
Ensure brevity in your answer.  2.03. What is the ratio of the Expenditure(as % of GDP) of 1997 in Panama to that in Philippines?
Your answer should be very brief. 1.97. What is the ratio of the Expenditure(as % of GDP) of 1998 in Panama to that in Philippines?
Keep it short and to the point. 2.22. What is the ratio of the Expenditure(as % of GDP) of 1995 in Panama to that in Poland?
Give a very brief answer. 1.41. What is the ratio of the Expenditure(as % of GDP) in 1996 in Panama to that in Poland?
Give a very brief answer. 1.22. What is the ratio of the Expenditure(as % of GDP) in 1997 in Panama to that in Poland?
Make the answer very short. 1.27. What is the ratio of the Expenditure(as % of GDP) of 1998 in Panama to that in Poland?
Make the answer very short. 1.2. What is the ratio of the Expenditure(as % of GDP) in 1995 in Papua New Guinea to that in Paraguay?
Your answer should be compact. 0.59. What is the ratio of the Expenditure(as % of GDP) of 1996 in Papua New Guinea to that in Paraguay?
Provide a short and direct response. 0.6. What is the ratio of the Expenditure(as % of GDP) in 1997 in Papua New Guinea to that in Paraguay?
Offer a very short reply. 0.54. What is the ratio of the Expenditure(as % of GDP) in 1998 in Papua New Guinea to that in Paraguay?
Provide a short and direct response. 0.61. What is the ratio of the Expenditure(as % of GDP) in 1995 in Papua New Guinea to that in Peru?
Provide a succinct answer. 0.77. What is the ratio of the Expenditure(as % of GDP) of 1996 in Papua New Guinea to that in Peru?
Your response must be concise. 0.8. What is the ratio of the Expenditure(as % of GDP) in 1997 in Papua New Guinea to that in Peru?
Your response must be concise. 0.76. What is the ratio of the Expenditure(as % of GDP) in 1998 in Papua New Guinea to that in Peru?
Make the answer very short. 0.83. What is the ratio of the Expenditure(as % of GDP) of 1995 in Papua New Guinea to that in Philippines?
Provide a succinct answer. 1.02. What is the ratio of the Expenditure(as % of GDP) of 1996 in Papua New Guinea to that in Philippines?
Your answer should be very brief. 1.03. What is the ratio of the Expenditure(as % of GDP) of 1997 in Papua New Guinea to that in Philippines?
Keep it short and to the point. 0.92. What is the ratio of the Expenditure(as % of GDP) in 1998 in Papua New Guinea to that in Philippines?
Keep it short and to the point. 1.19. What is the ratio of the Expenditure(as % of GDP) of 1995 in Papua New Guinea to that in Poland?
Offer a very short reply. 0.64. What is the ratio of the Expenditure(as % of GDP) in 1996 in Papua New Guinea to that in Poland?
Keep it short and to the point. 0.62. What is the ratio of the Expenditure(as % of GDP) in 1997 in Papua New Guinea to that in Poland?
Offer a terse response. 0.6. What is the ratio of the Expenditure(as % of GDP) in 1998 in Papua New Guinea to that in Poland?
Offer a terse response. 0.65. What is the ratio of the Expenditure(as % of GDP) in 1995 in Paraguay to that in Peru?
Make the answer very short. 1.3. What is the ratio of the Expenditure(as % of GDP) in 1996 in Paraguay to that in Peru?
Make the answer very short. 1.33. What is the ratio of the Expenditure(as % of GDP) in 1997 in Paraguay to that in Peru?
Provide a short and direct response. 1.4. What is the ratio of the Expenditure(as % of GDP) of 1998 in Paraguay to that in Peru?
Offer a very short reply. 1.36. What is the ratio of the Expenditure(as % of GDP) in 1995 in Paraguay to that in Philippines?
Ensure brevity in your answer.  1.72. What is the ratio of the Expenditure(as % of GDP) in 1996 in Paraguay to that in Philippines?
Provide a short and direct response. 1.72. What is the ratio of the Expenditure(as % of GDP) of 1997 in Paraguay to that in Philippines?
Give a very brief answer. 1.71. What is the ratio of the Expenditure(as % of GDP) in 1998 in Paraguay to that in Philippines?
Your response must be concise. 1.96. What is the ratio of the Expenditure(as % of GDP) in 1995 in Paraguay to that in Poland?
Your response must be concise. 1.08. What is the ratio of the Expenditure(as % of GDP) of 1996 in Paraguay to that in Poland?
Keep it short and to the point. 1.03. What is the ratio of the Expenditure(as % of GDP) in 1997 in Paraguay to that in Poland?
Keep it short and to the point. 1.1. What is the ratio of the Expenditure(as % of GDP) of 1998 in Paraguay to that in Poland?
Your response must be concise. 1.06. What is the ratio of the Expenditure(as % of GDP) of 1995 in Peru to that in Philippines?
Ensure brevity in your answer.  1.32. What is the ratio of the Expenditure(as % of GDP) in 1996 in Peru to that in Philippines?
Offer a terse response. 1.29. What is the ratio of the Expenditure(as % of GDP) of 1997 in Peru to that in Philippines?
Your response must be concise. 1.22. What is the ratio of the Expenditure(as % of GDP) of 1998 in Peru to that in Philippines?
Your answer should be compact. 1.44. What is the ratio of the Expenditure(as % of GDP) of 1995 in Peru to that in Poland?
Ensure brevity in your answer.  0.83. What is the ratio of the Expenditure(as % of GDP) in 1996 in Peru to that in Poland?
Make the answer very short. 0.78. What is the ratio of the Expenditure(as % of GDP) in 1997 in Peru to that in Poland?
Make the answer very short. 0.79. What is the ratio of the Expenditure(as % of GDP) in 1998 in Peru to that in Poland?
Your response must be concise. 0.78. What is the ratio of the Expenditure(as % of GDP) in 1995 in Philippines to that in Poland?
Provide a succinct answer. 0.63. What is the ratio of the Expenditure(as % of GDP) of 1996 in Philippines to that in Poland?
Your answer should be very brief. 0.6. What is the ratio of the Expenditure(as % of GDP) of 1997 in Philippines to that in Poland?
Your answer should be very brief. 0.65. What is the ratio of the Expenditure(as % of GDP) of 1998 in Philippines to that in Poland?
Offer a very short reply. 0.54. What is the difference between the highest and the second highest Expenditure(as % of GDP) of 1995?
Provide a short and direct response. 1.8. What is the difference between the highest and the second highest Expenditure(as % of GDP) of 1996?
Provide a succinct answer. 1.11. What is the difference between the highest and the second highest Expenditure(as % of GDP) of 1997?
Provide a short and direct response. 0.93. What is the difference between the highest and the second highest Expenditure(as % of GDP) in 1998?
Your answer should be very brief. 0.8. What is the difference between the highest and the lowest Expenditure(as % of GDP) of 1995?
Your answer should be compact. 4.27. What is the difference between the highest and the lowest Expenditure(as % of GDP) of 1996?
Make the answer very short. 3.64. What is the difference between the highest and the lowest Expenditure(as % of GDP) of 1997?
Give a very brief answer. 3.77. What is the difference between the highest and the lowest Expenditure(as % of GDP) in 1998?
Make the answer very short. 3.89. 